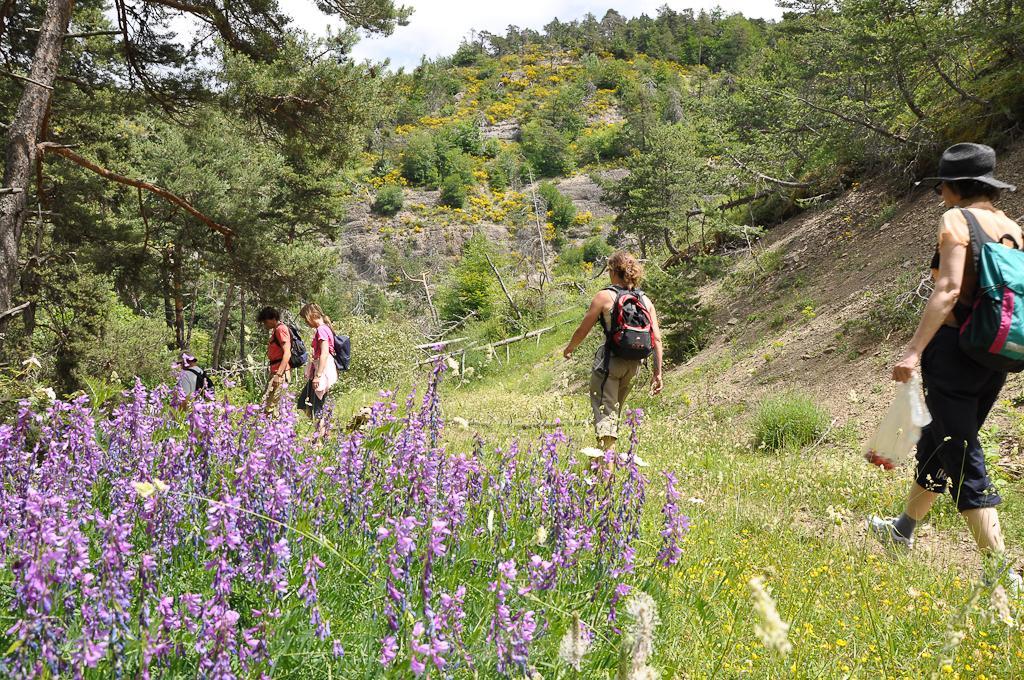Can you describe this image briefly? This is an outside view. Here I can see five people wearing bags and walking on the ground. At the bottom of the image I can see many plants along with the flowers. In the background, I can see many trees, plants and hill. At the top I can see the sky. 